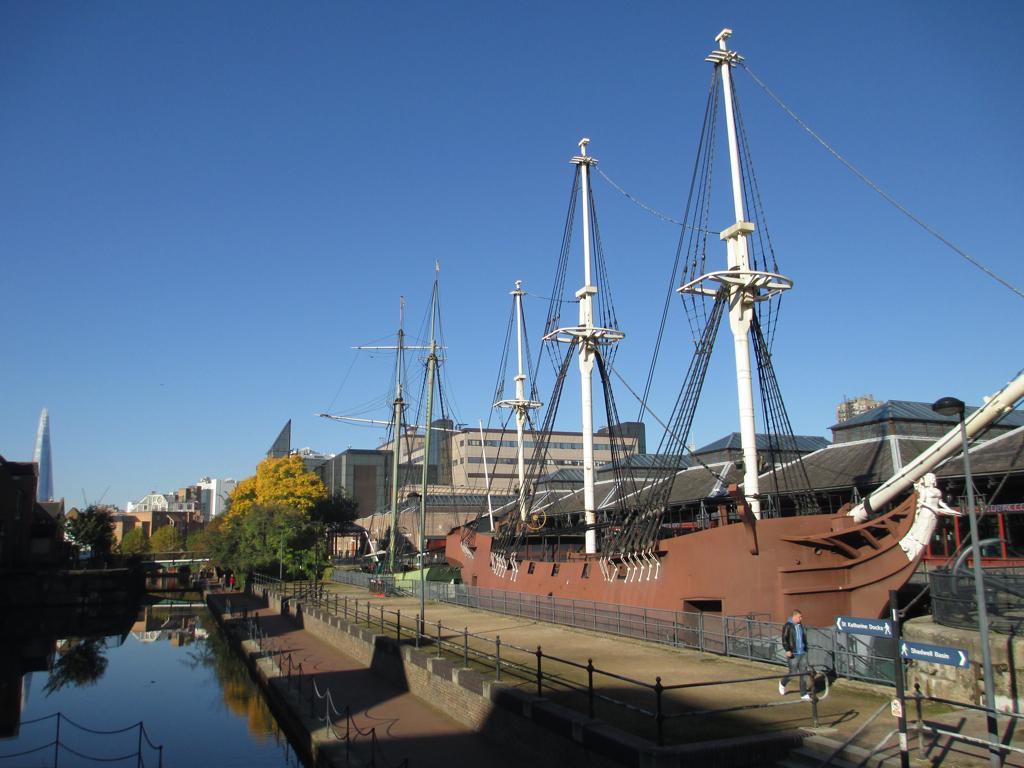Describe this image in one or two sentences. In this picture I can observe a ship which is in brown color. There are some poles in this picture. On the left side I can observe water. There is a person walking on the land on the right side. In the background there are buildings, trees and a sky. 